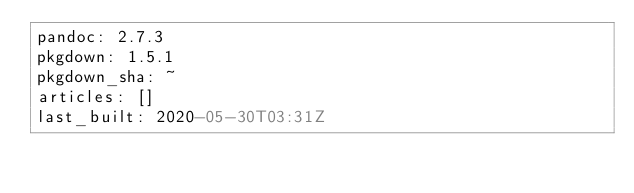<code> <loc_0><loc_0><loc_500><loc_500><_YAML_>pandoc: 2.7.3
pkgdown: 1.5.1
pkgdown_sha: ~
articles: []
last_built: 2020-05-30T03:31Z

</code> 